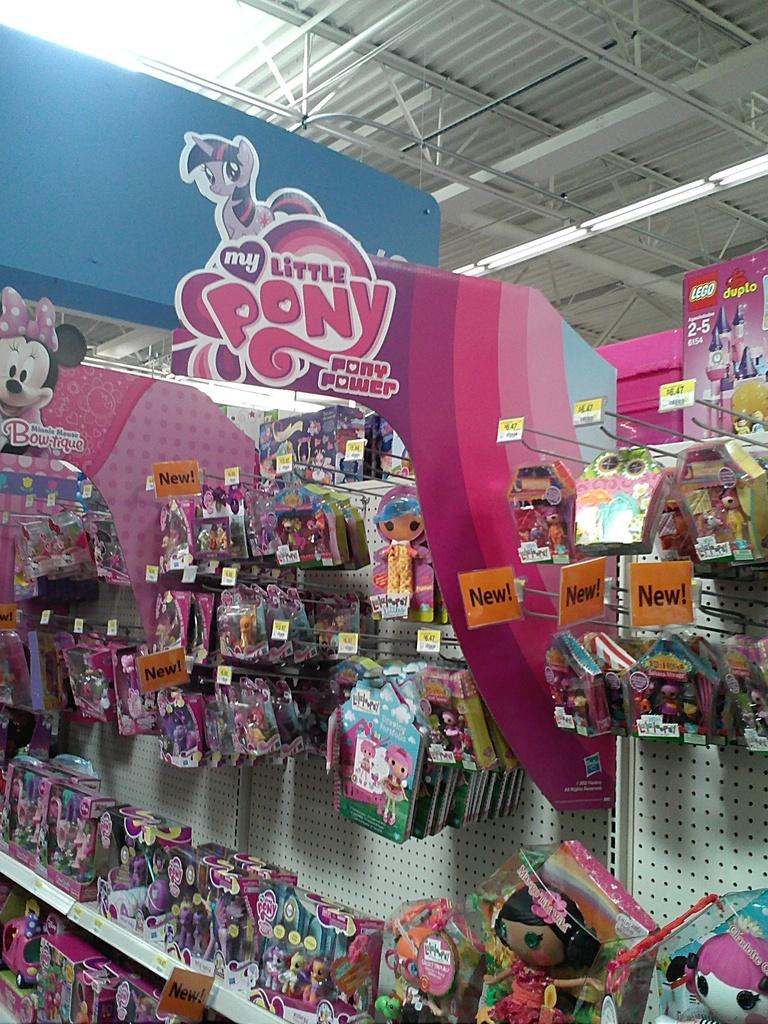What toy is shown in the sign?
Your response must be concise. My little pony. What condition are the toys?
Offer a very short reply. New. 